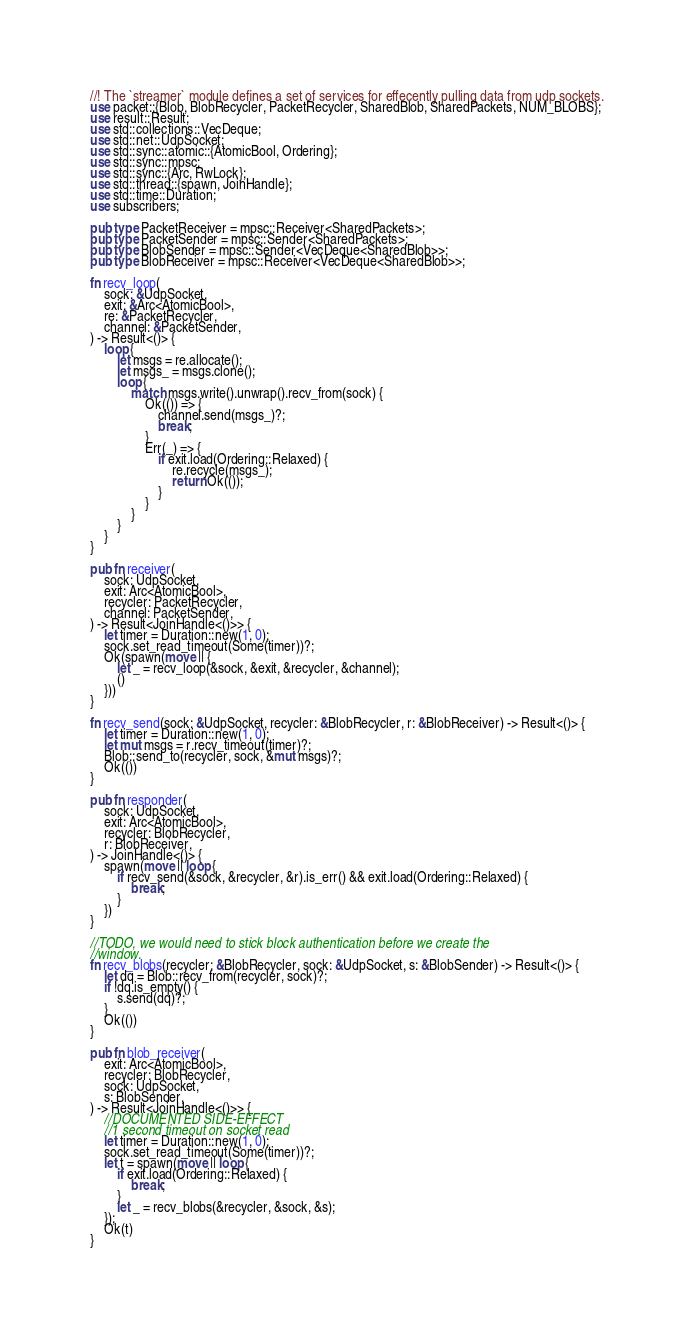<code> <loc_0><loc_0><loc_500><loc_500><_Rust_>//! The `streamer` module defines a set of services for effecently pulling data from udp sockets.
use packet::{Blob, BlobRecycler, PacketRecycler, SharedBlob, SharedPackets, NUM_BLOBS};
use result::Result;
use std::collections::VecDeque;
use std::net::UdpSocket;
use std::sync::atomic::{AtomicBool, Ordering};
use std::sync::mpsc;
use std::sync::{Arc, RwLock};
use std::thread::{spawn, JoinHandle};
use std::time::Duration;
use subscribers;

pub type PacketReceiver = mpsc::Receiver<SharedPackets>;
pub type PacketSender = mpsc::Sender<SharedPackets>;
pub type BlobSender = mpsc::Sender<VecDeque<SharedBlob>>;
pub type BlobReceiver = mpsc::Receiver<VecDeque<SharedBlob>>;

fn recv_loop(
    sock: &UdpSocket,
    exit: &Arc<AtomicBool>,
    re: &PacketRecycler,
    channel: &PacketSender,
) -> Result<()> {
    loop {
        let msgs = re.allocate();
        let msgs_ = msgs.clone();
        loop {
            match msgs.write().unwrap().recv_from(sock) {
                Ok(()) => {
                    channel.send(msgs_)?;
                    break;
                }
                Err(_) => {
                    if exit.load(Ordering::Relaxed) {
                        re.recycle(msgs_);
                        return Ok(());
                    }
                }
            }
        }
    }
}

pub fn receiver(
    sock: UdpSocket,
    exit: Arc<AtomicBool>,
    recycler: PacketRecycler,
    channel: PacketSender,
) -> Result<JoinHandle<()>> {
    let timer = Duration::new(1, 0);
    sock.set_read_timeout(Some(timer))?;
    Ok(spawn(move || {
        let _ = recv_loop(&sock, &exit, &recycler, &channel);
        ()
    }))
}

fn recv_send(sock: &UdpSocket, recycler: &BlobRecycler, r: &BlobReceiver) -> Result<()> {
    let timer = Duration::new(1, 0);
    let mut msgs = r.recv_timeout(timer)?;
    Blob::send_to(recycler, sock, &mut msgs)?;
    Ok(())
}

pub fn responder(
    sock: UdpSocket,
    exit: Arc<AtomicBool>,
    recycler: BlobRecycler,
    r: BlobReceiver,
) -> JoinHandle<()> {
    spawn(move || loop {
        if recv_send(&sock, &recycler, &r).is_err() && exit.load(Ordering::Relaxed) {
            break;
        }
    })
}

//TODO, we would need to stick block authentication before we create the
//window.
fn recv_blobs(recycler: &BlobRecycler, sock: &UdpSocket, s: &BlobSender) -> Result<()> {
    let dq = Blob::recv_from(recycler, sock)?;
    if !dq.is_empty() {
        s.send(dq)?;
    }
    Ok(())
}

pub fn blob_receiver(
    exit: Arc<AtomicBool>,
    recycler: BlobRecycler,
    sock: UdpSocket,
    s: BlobSender,
) -> Result<JoinHandle<()>> {
    //DOCUMENTED SIDE-EFFECT
    //1 second timeout on socket read
    let timer = Duration::new(1, 0);
    sock.set_read_timeout(Some(timer))?;
    let t = spawn(move || loop {
        if exit.load(Ordering::Relaxed) {
            break;
        }
        let _ = recv_blobs(&recycler, &sock, &s);
    });
    Ok(t)
}
</code> 